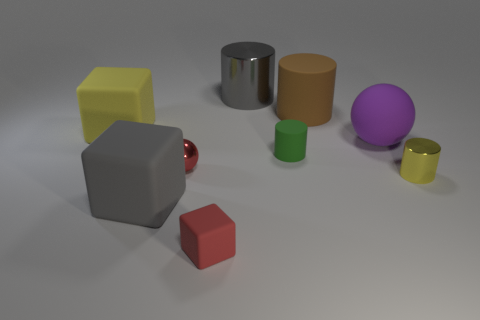Does the metallic ball have the same color as the tiny cube?
Make the answer very short. Yes. How many rubber objects are large purple objects or big purple cylinders?
Give a very brief answer. 1. What is the size of the green cylinder that is on the right side of the small red thing that is in front of the large gray object that is in front of the tiny yellow cylinder?
Ensure brevity in your answer.  Small. There is a thing that is both behind the purple matte thing and on the right side of the large shiny thing; what is its size?
Offer a terse response. Large. Is the color of the big metal thing that is right of the large yellow matte cube the same as the small metallic thing that is on the left side of the purple sphere?
Offer a very short reply. No. What number of small things are behind the big gray cylinder?
Offer a terse response. 0. There is a metal cylinder in front of the object on the left side of the big gray rubber block; are there any yellow cylinders behind it?
Provide a succinct answer. No. What number of other things are the same size as the gray matte object?
Offer a very short reply. 4. What is the small red thing behind the large gray thing in front of the metallic ball made of?
Give a very brief answer. Metal. What is the shape of the big gray object that is in front of the yellow rubber block that is left of the rubber cylinder in front of the yellow cube?
Provide a short and direct response. Cube. 